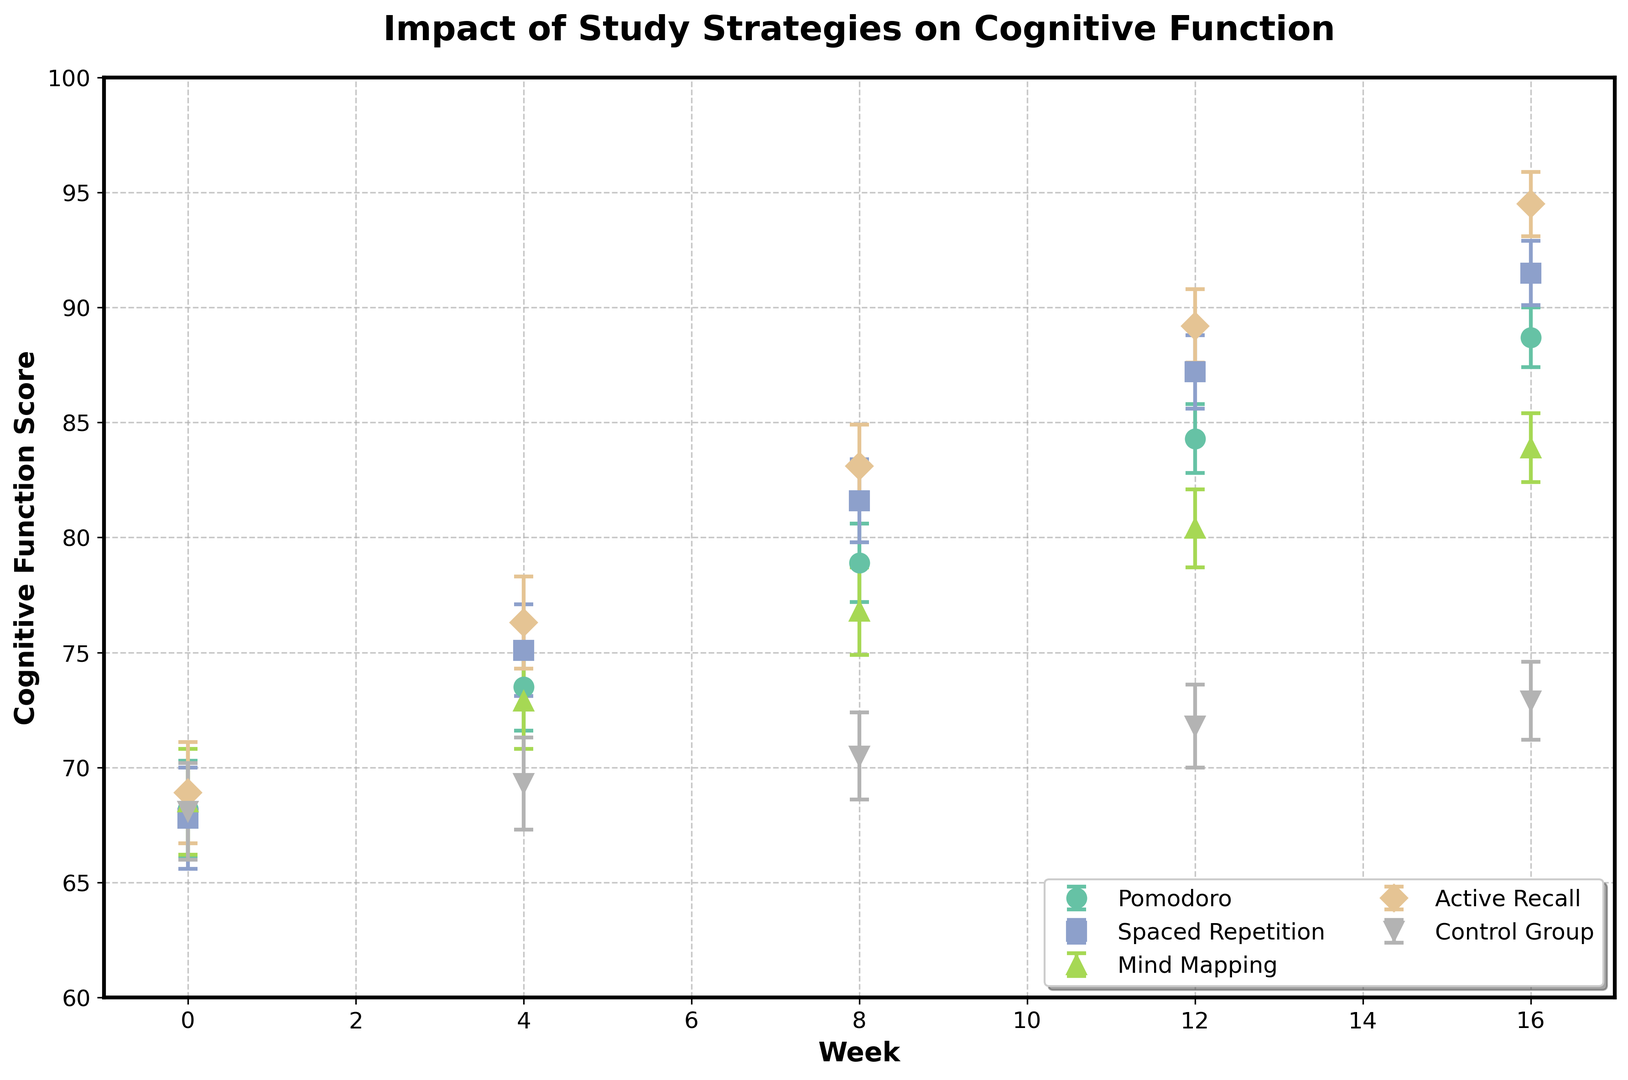What is the average cognitive function score of the Pomodoro group at the beginning and end of the semester? To find the average score for the Pomodoro group, take the scores at the first (week 0) and the last (week 16) measurements, then compute the mean. (68.2 + 88.7) / 2 = 78.45
Answer: 78.45 Which study strategy showed the greatest improvement in cognitive function scores over the semester? To determine the greatest improvement, calculate the difference between the week 16 and week 0 scores for each strategy, then identify the largest difference. Pomodoro: 88.7 - 68.2 = 20.5, Spaced Repetition: 91.5 - 67.8 = 23.7, Mind Mapping: 83.9 - 68.5 = 15.4, Active Recall: 94.5 - 68.9 = 25.6, Control Group: 72.9 - 68.1 = 4.8. Active Recall has the greatest improvement.
Answer: Active Recall How do the cognitive function scores for Mind Mapping and Spaced Repetition compare at week 8? Compare the values directly from the figure. Mind Mapping: 76.8, Spaced Repetition: 81.6. Therefore, Spaced Repetition's score is higher.
Answer: Spaced Repetition What is the range (difference between highest and lowest scores) of the cognitive function scores for Active Recall across the semester? Identify the highest and lowest scores for Active Recall from the figure: highest at week 16: 94.5, lowest at week 0: 68.9, and calculate the difference: 94.5 - 68.9 = 25.6.
Answer: 25.6 Which strategy had the most consistent increase in cognitive function scores over the semester? To determine consistency, observe the gradual and steady increments in scores. Pomodoro: steadily increases by about 5-6 points at each interval. Thus, Pomodoro shows the most consistent increase.
Answer: Pomodoro Between Pomodoro and Control Group, which strategy shows a statistically significant improvement from week 0 to week 4, considering the error bars? Compare the mean scores and the standard errors at week 0 and week 4 for both groups. For Pomodoro, week 4 improvement: 73.5 +/- 1.9 and week 0: 68.2 +/- 2.1; overlap is small, suggesting improvement. For Control: week 4: 69.3 +/- 2.0 and week 0: 68.1 +/- 2.1; overlap indicates less significant change. Therefore, Pomodoro shows a statistically significant improvement.
Answer: Pomodoro Which strategy had a higher cognitive function score than the Control Group at every single data point? From the plot, observe the scores over time for each strategy and the Control Group. Pomodoro, Spaced Repetition, Mind Mapping, and Active Recall all have higher scores than the Control Group at every time point.
Answer: Pomodoro, Spaced Repetition, Mind Mapping, Active Recall At week 12, how does the score of Spaced Repetition compare to the average score of the Control Group? Find the score of Spaced Repetition at week 12 (87.2) and the average of the Control Group scores over all weeks ((68.1 + 69.3 + 70.5 + 71.8 + 72.9) / 5 = 70.52), then compare. 87.2 > 70.52
Answer: Higher Which strategy has the lowest improvement in cognitive function scores from week 0 to week 8? Calculate the difference between week 8 and week 0 scores for all strategies, and identify the smallest difference. Pomodoro: 78.9 - 68.2 = 10.7, Spaced Repetition: 81.6 - 67.8 = 13.8, Mind Mapping: 76.8 - 68.5 = 8.3, Active Recall: 83.1 - 68.9 = 14.2, Control: 70.5 - 68.1 = 2.4. Control Group has the lowest improvement.
Answer: Control Group 